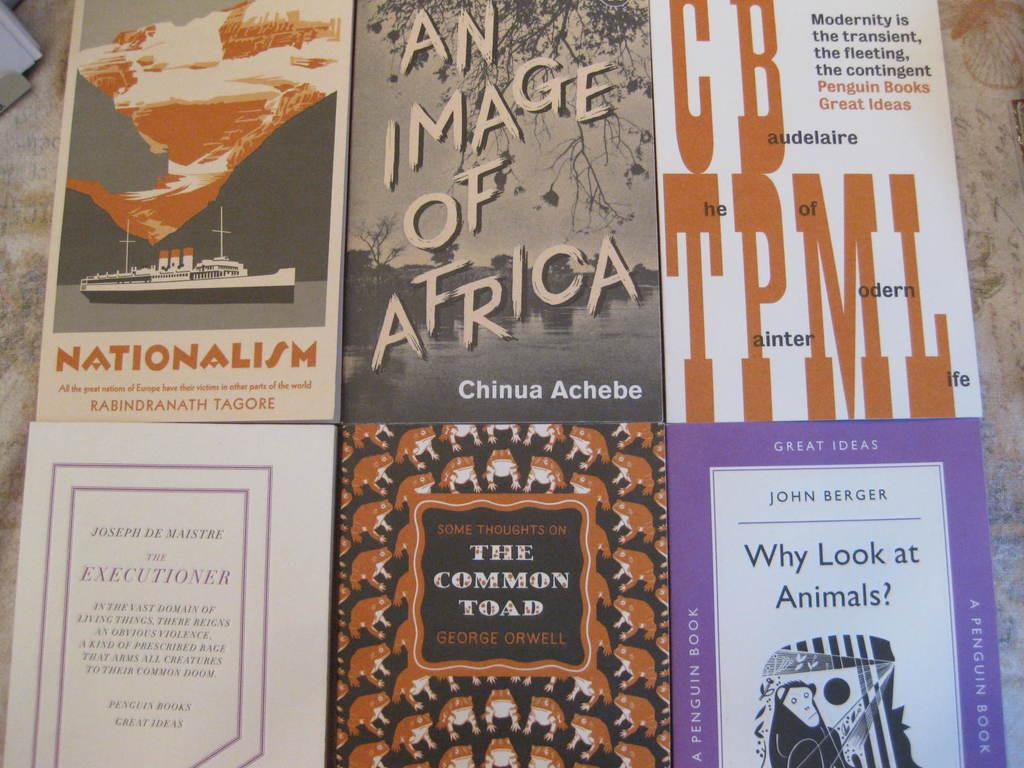<image>
Offer a succinct explanation of the picture presented. A collection of books includes the title An Image of Africa, by Chinua Achebe. 